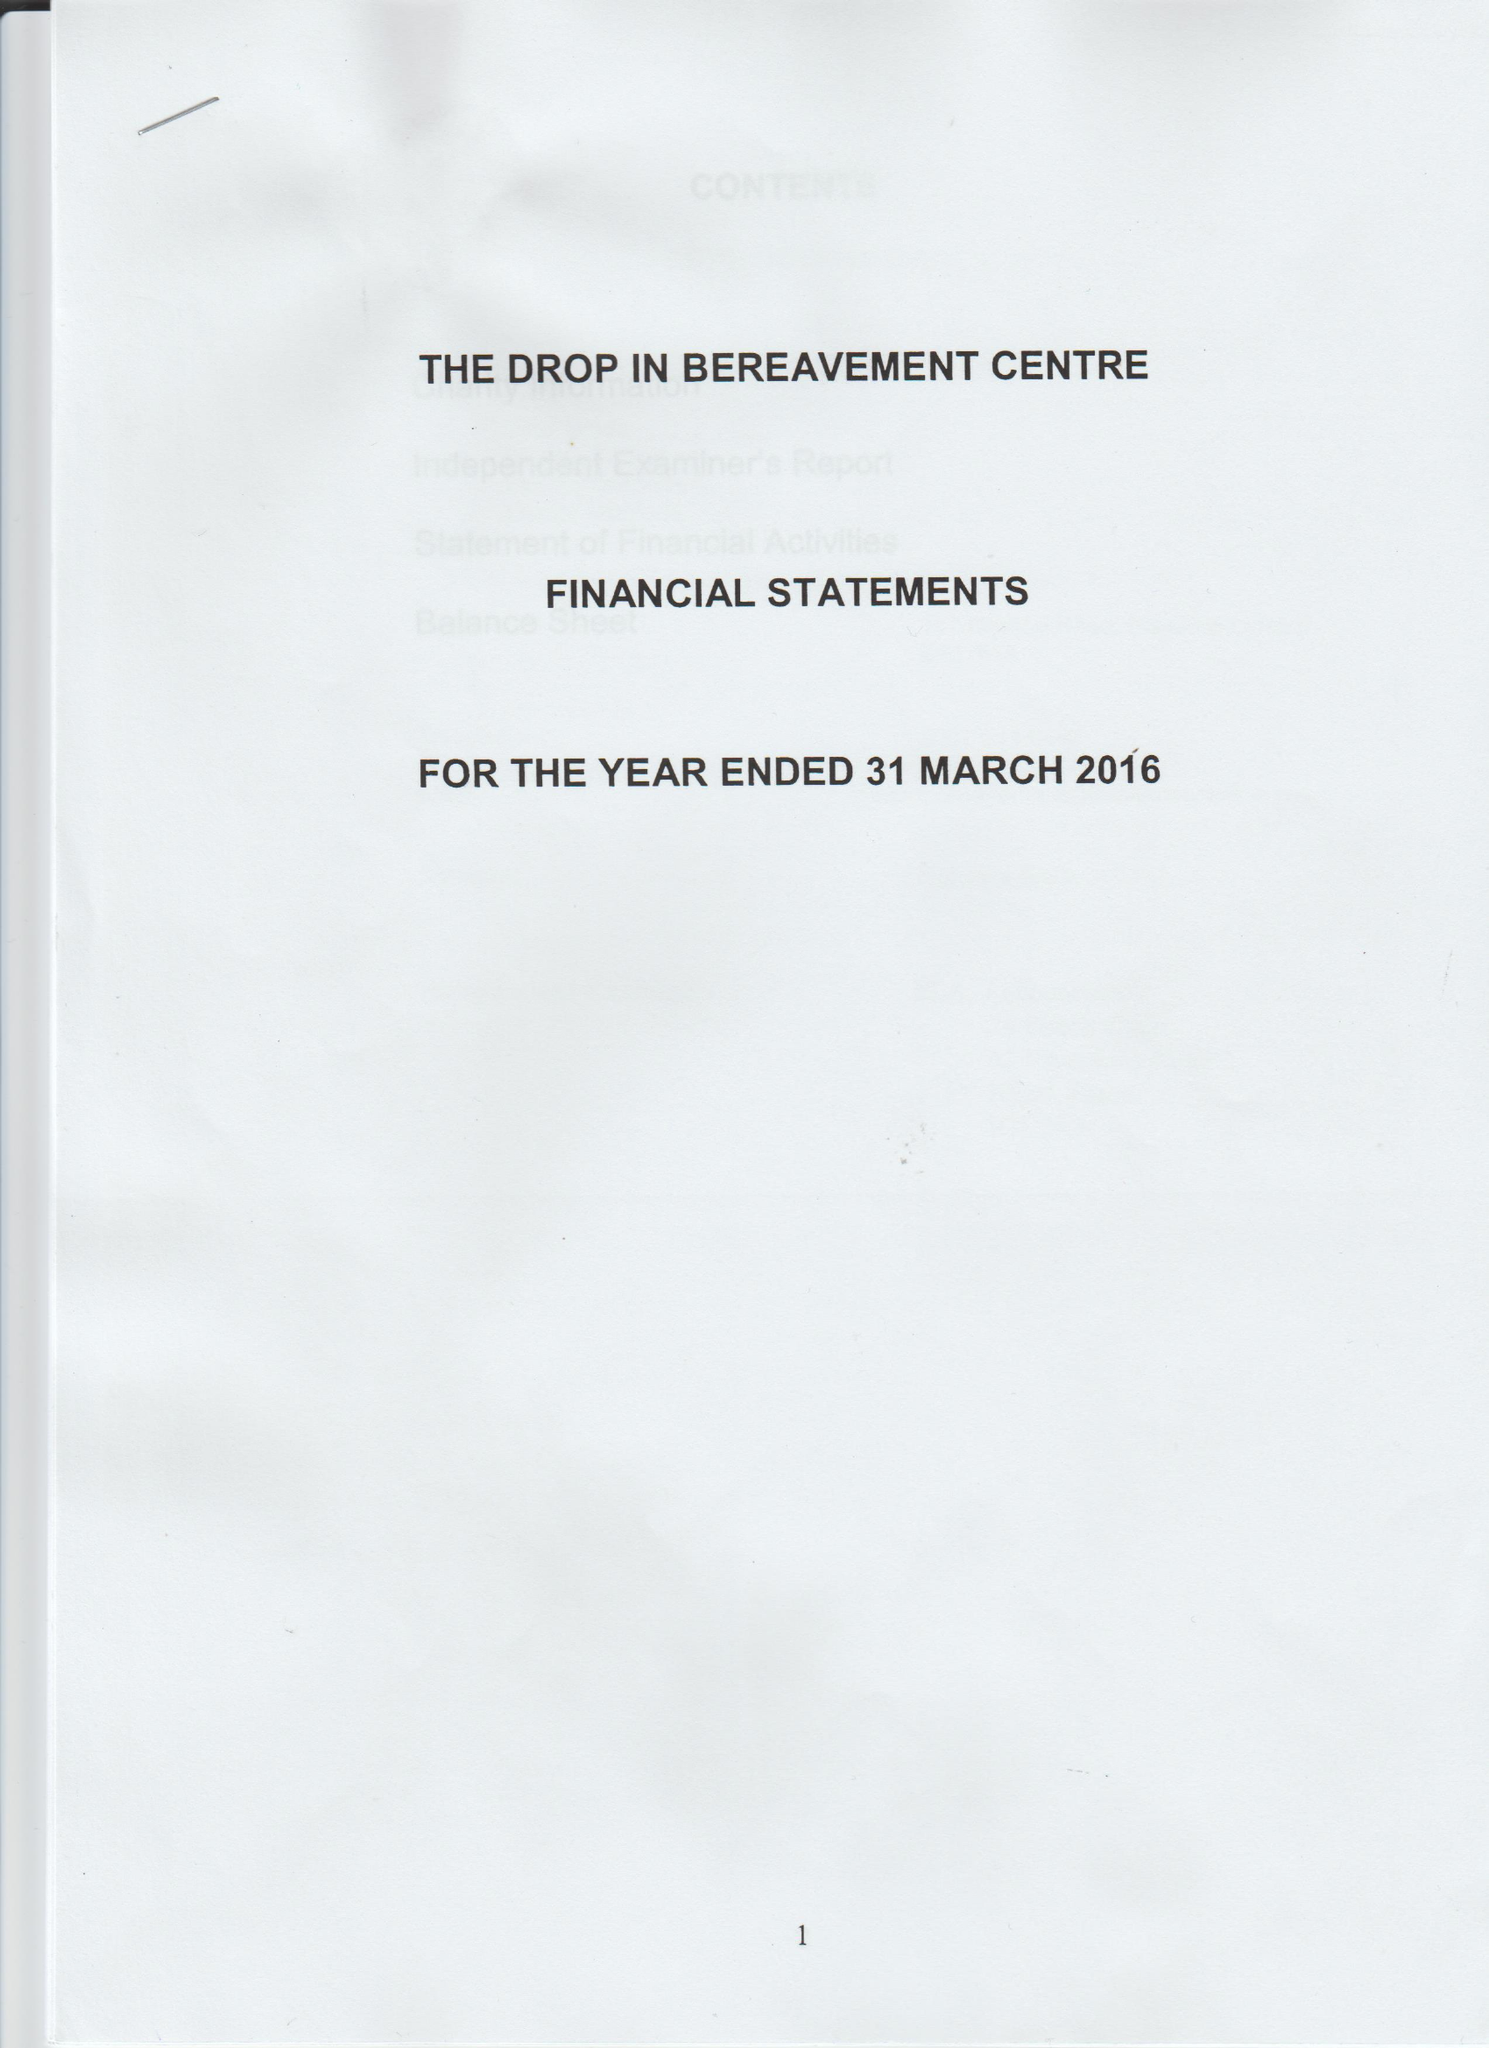What is the value for the spending_annually_in_british_pounds?
Answer the question using a single word or phrase. 38385.00 